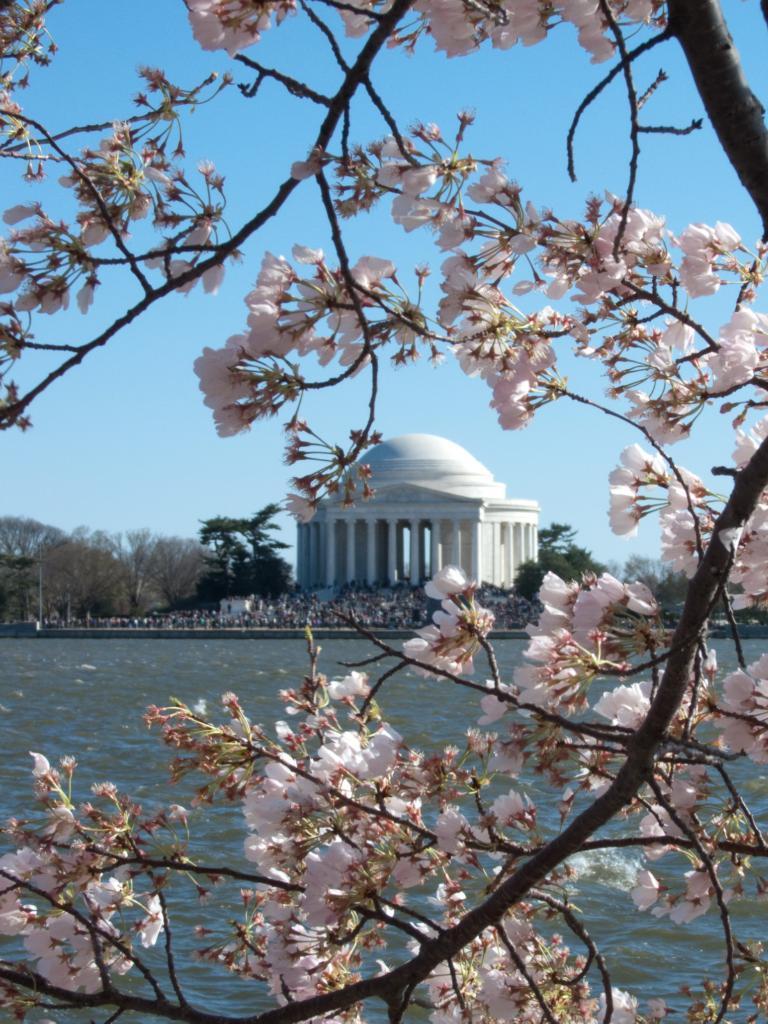In one or two sentences, can you explain what this image depicts? In the image there are white flowers to the branches of a tree, behind that there is a water surface and behind the water surface there are few trees and behind that there is a white architecture. 